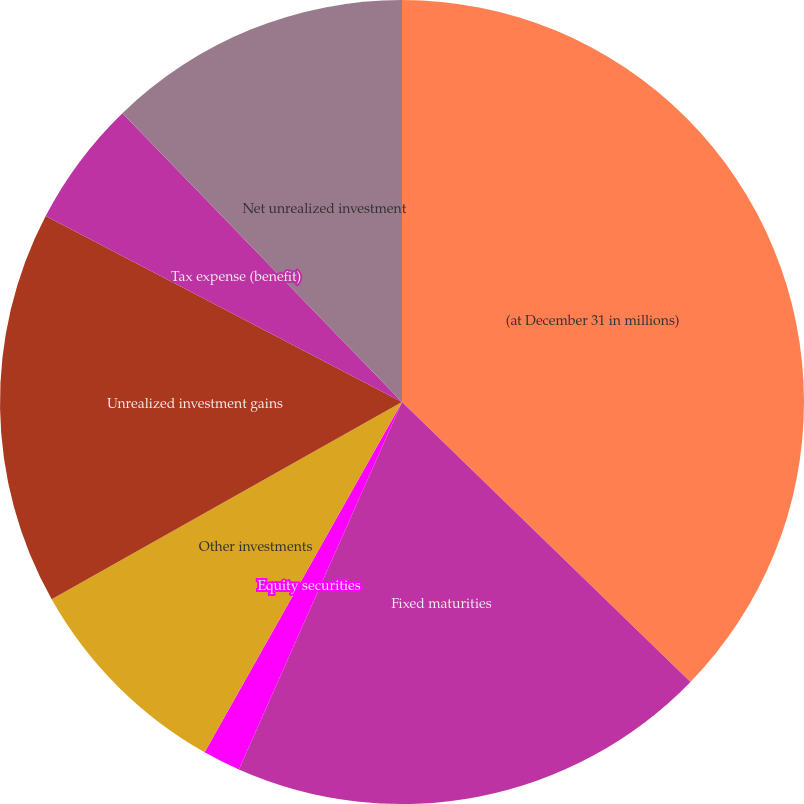Convert chart. <chart><loc_0><loc_0><loc_500><loc_500><pie_chart><fcel>(at December 31 in millions)<fcel>Fixed maturities<fcel>Equity securities<fcel>Other investments<fcel>Unrealized investment gains<fcel>Tax expense (benefit)<fcel>Net unrealized investment<nl><fcel>37.26%<fcel>19.39%<fcel>1.52%<fcel>8.67%<fcel>15.82%<fcel>5.1%<fcel>12.24%<nl></chart> 